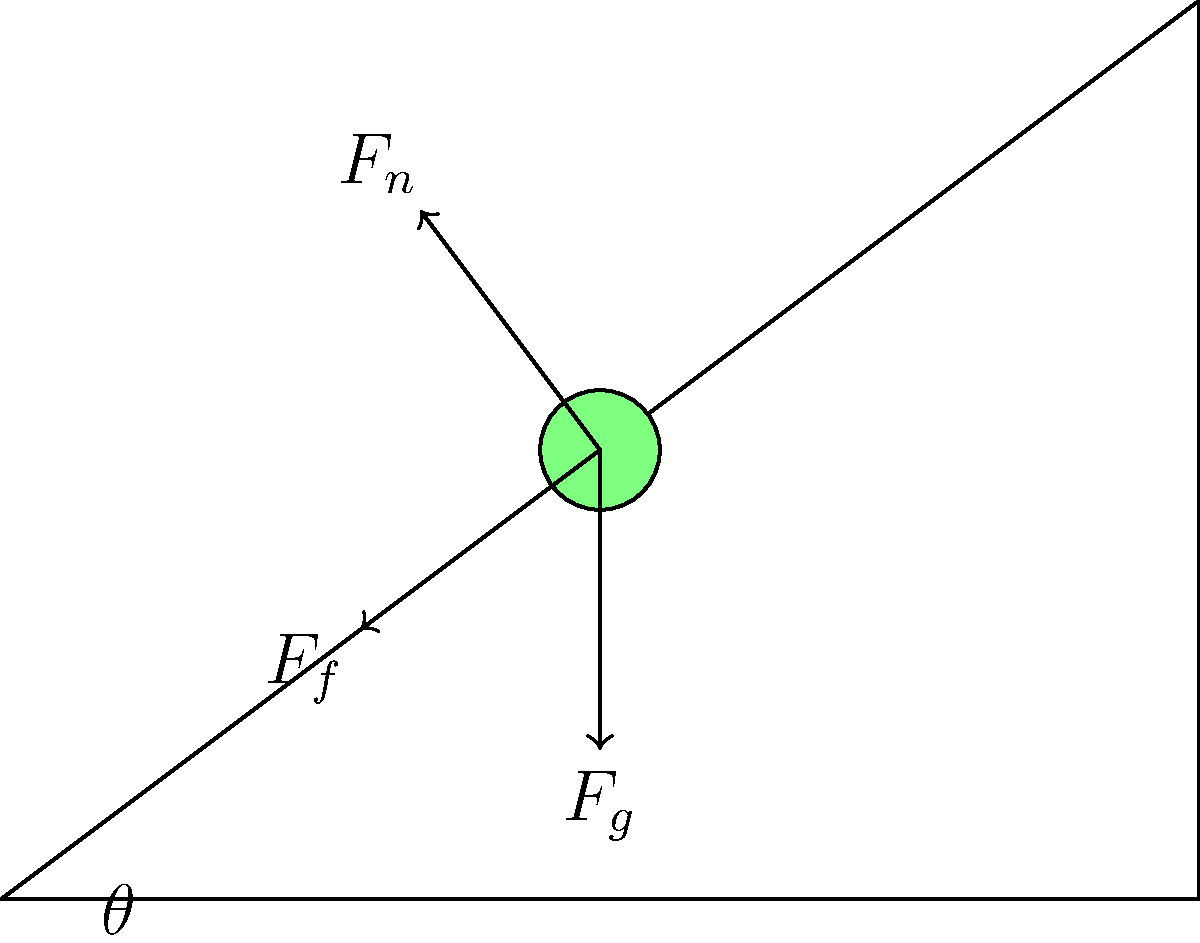As a digital media specialist verifying online information about physics, you encounter a diagram showing an object on an inclined plane. The plane makes an angle $\theta$ with the horizontal, and three forces are acting on the object: gravitational force ($F_g$), normal force ($F_n$), and friction force ($F_f$). If the object is at rest, which of these forces must be equal in magnitude but opposite in direction to the component of the gravitational force parallel to the inclined plane? To answer this question, let's break down the forces and their components:

1. Gravitational force ($F_g$):
   - Acts vertically downward
   - Can be decomposed into two components:
     a) Parallel to the inclined plane: $F_g \sin(\theta)$
     b) Perpendicular to the inclined plane: $F_g \cos(\theta)$

2. Normal force ($F_n$):
   - Acts perpendicular to the inclined plane
   - Balances the perpendicular component of $F_g$
   - $F_n = F_g \cos(\theta)$

3. Friction force ($F_f$):
   - Acts parallel to the inclined plane, in the opposite direction of potential motion
   - Prevents the object from sliding down the plane

For the object to be at rest, the sum of all forces must be zero. This means:

4. The force parallel to the plane must be balanced:
   $F_f = F_g \sin(\theta)$

5. The forces perpendicular to the plane are already balanced by the normal force.

Therefore, the friction force ($F_f$) must be equal in magnitude but opposite in direction to the component of the gravitational force parallel to the inclined plane ($F_g \sin(\theta)$).
Answer: Friction force ($F_f$) 